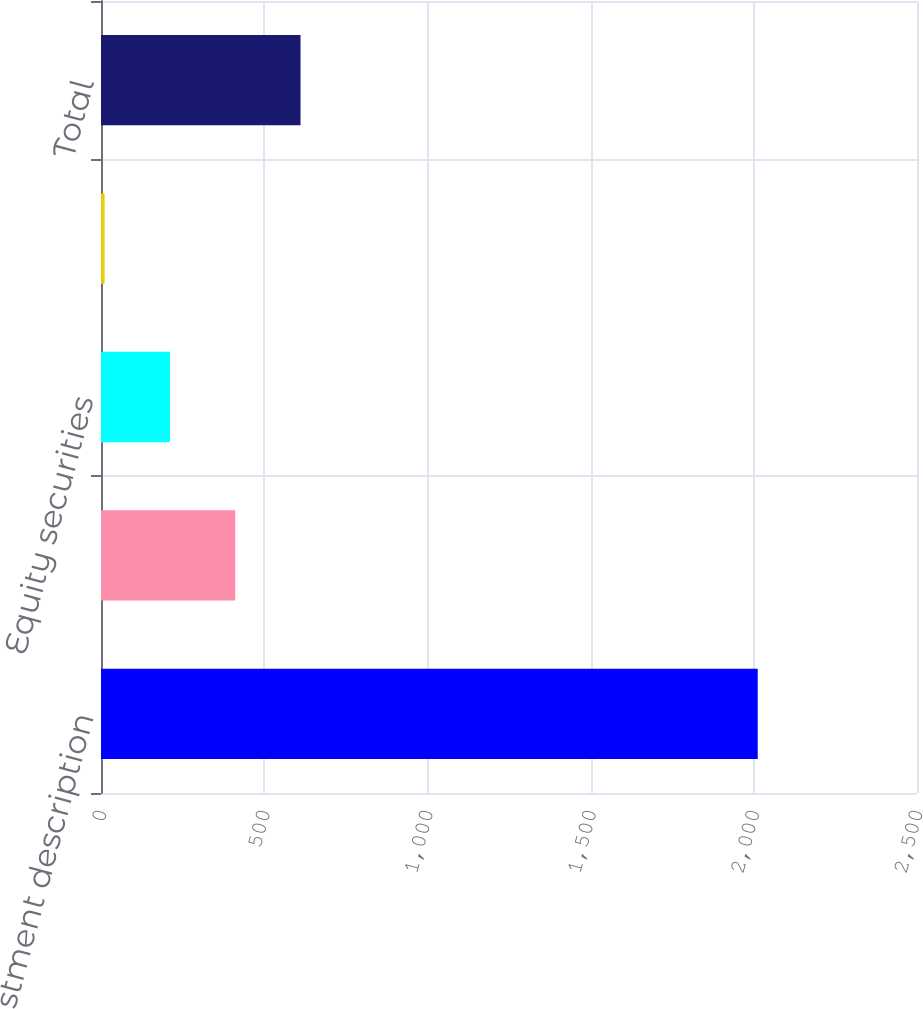Convert chart to OTSL. <chart><loc_0><loc_0><loc_500><loc_500><bar_chart><fcel>Investment description<fcel>Fixed income<fcel>Equity securities<fcel>Real estate/other<fcel>Total<nl><fcel>2012<fcel>411.2<fcel>211.1<fcel>11<fcel>611.3<nl></chart> 